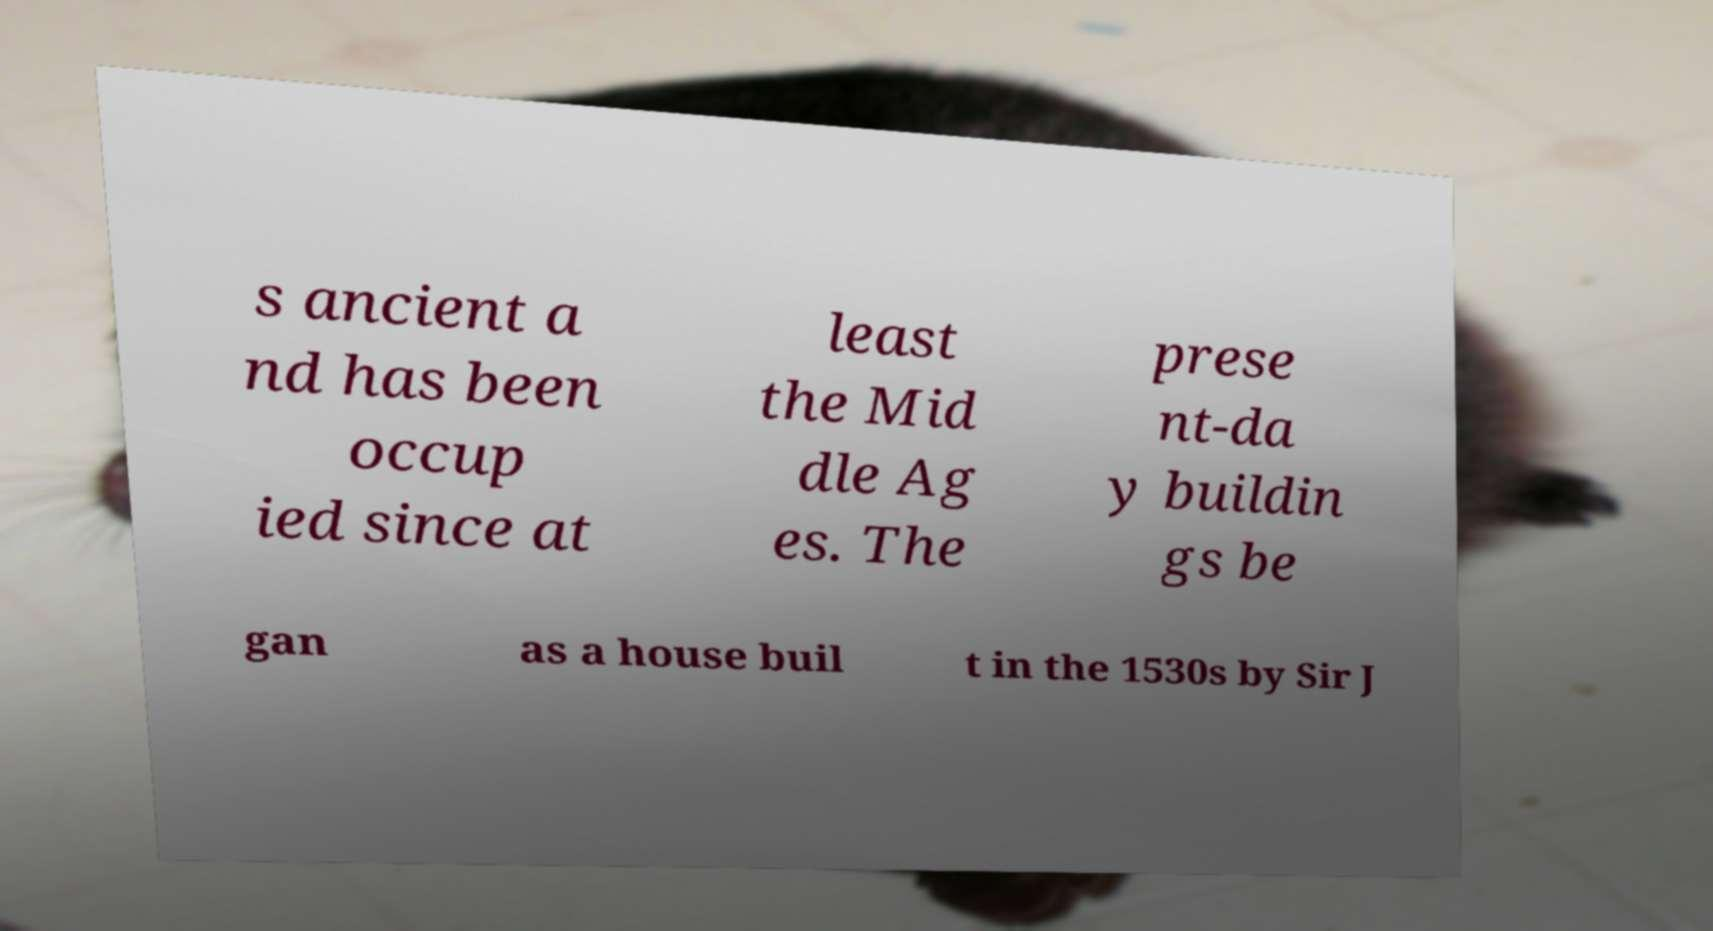What messages or text are displayed in this image? I need them in a readable, typed format. s ancient a nd has been occup ied since at least the Mid dle Ag es. The prese nt-da y buildin gs be gan as a house buil t in the 1530s by Sir J 